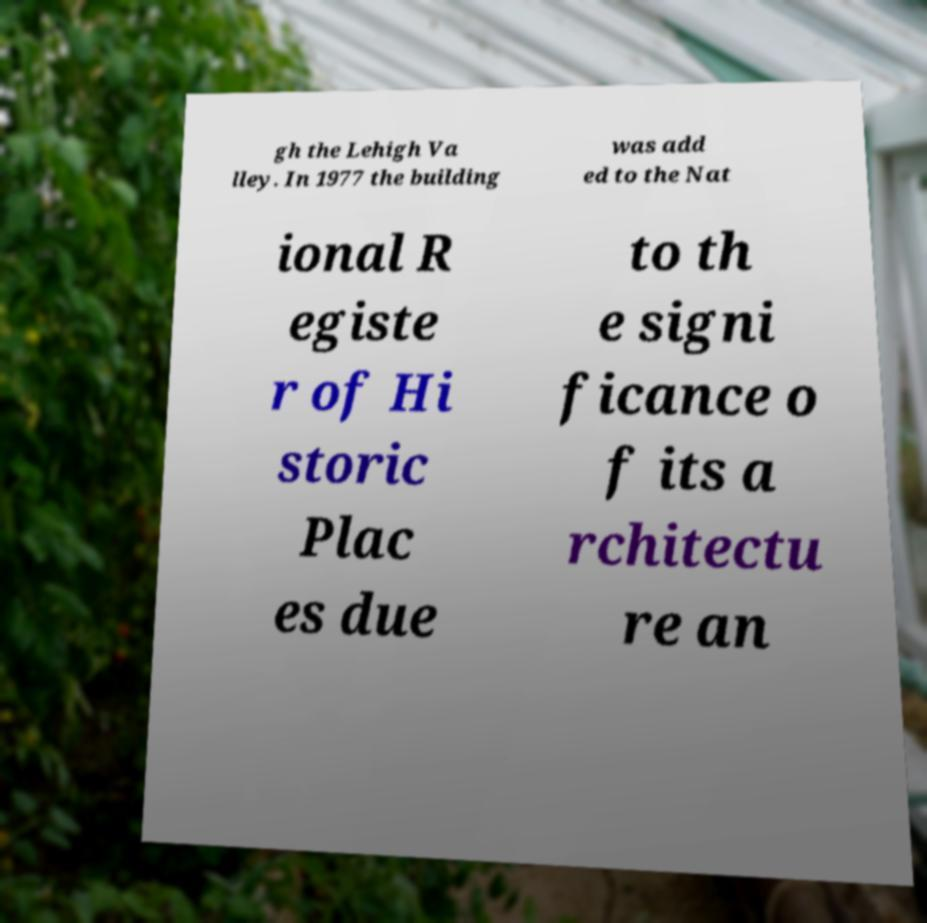Can you read and provide the text displayed in the image?This photo seems to have some interesting text. Can you extract and type it out for me? gh the Lehigh Va lley. In 1977 the building was add ed to the Nat ional R egiste r of Hi storic Plac es due to th e signi ficance o f its a rchitectu re an 